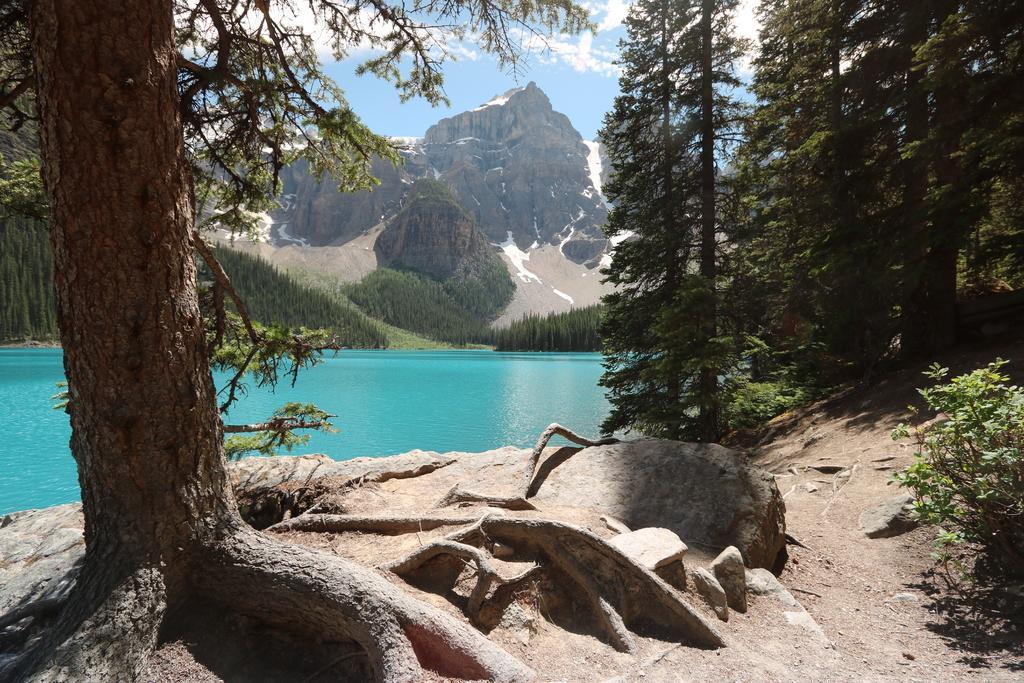Describe this image in one or two sentences. In the center of the image, there is a sea and in the background, there are mountains, trees and some other plants. 